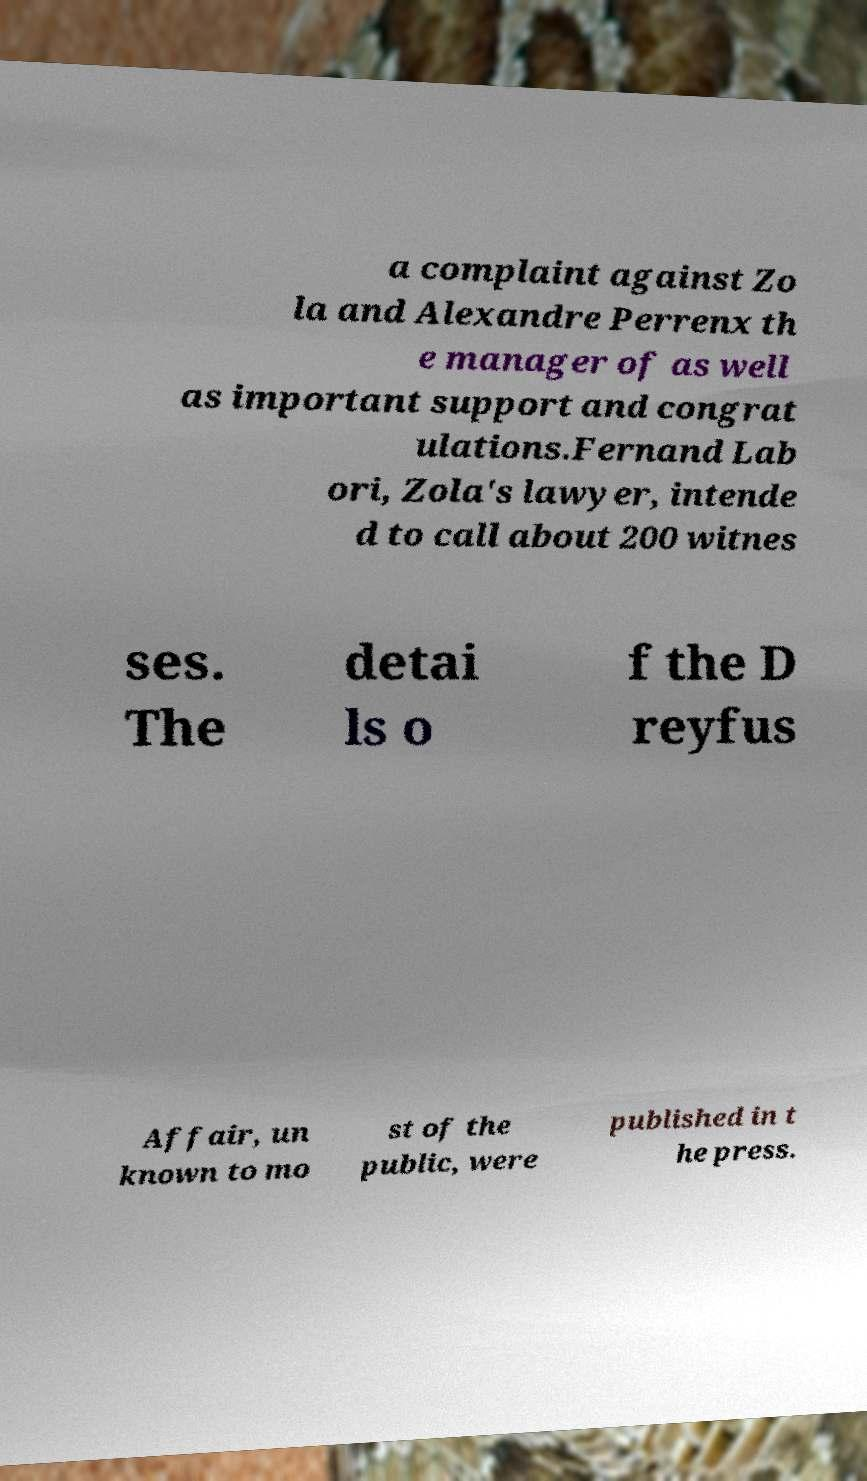What messages or text are displayed in this image? I need them in a readable, typed format. a complaint against Zo la and Alexandre Perrenx th e manager of as well as important support and congrat ulations.Fernand Lab ori, Zola's lawyer, intende d to call about 200 witnes ses. The detai ls o f the D reyfus Affair, un known to mo st of the public, were published in t he press. 